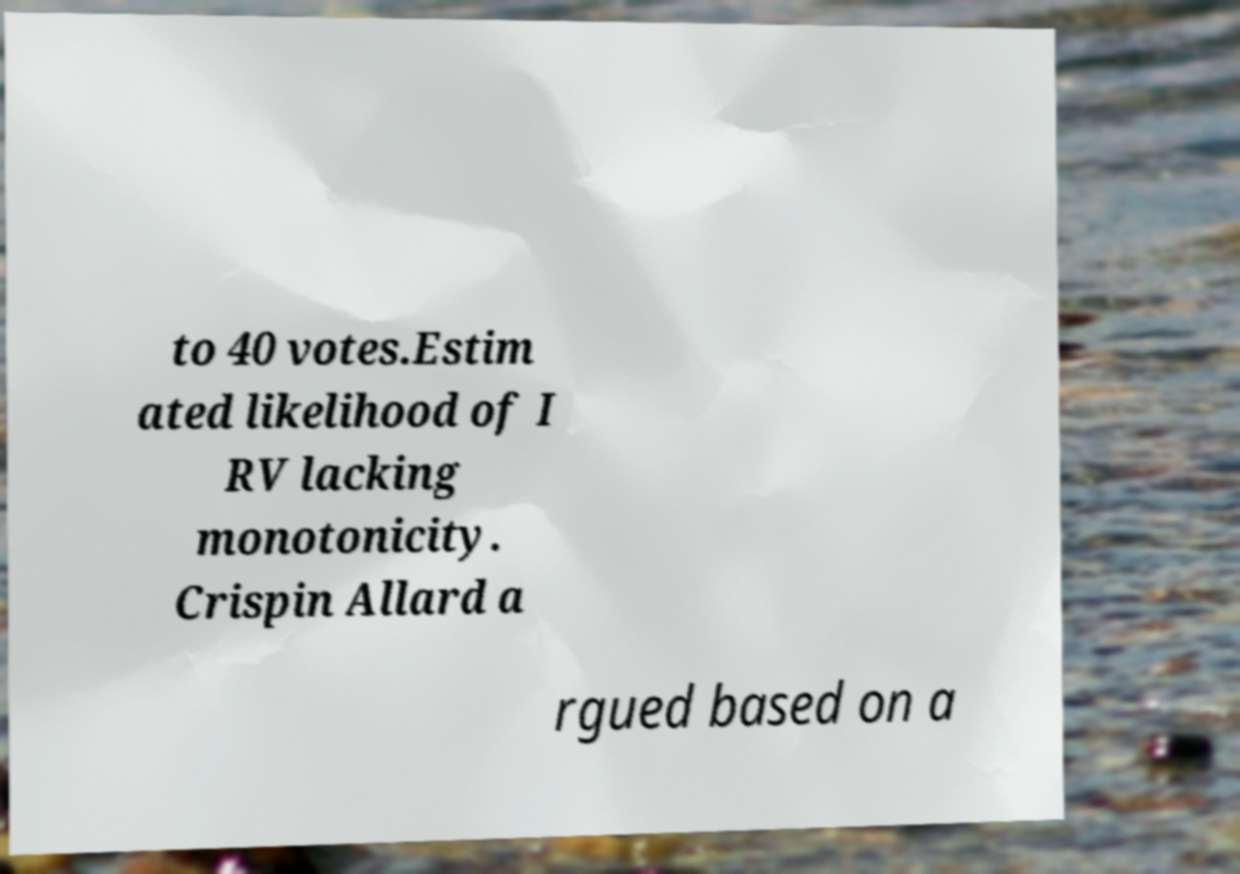I need the written content from this picture converted into text. Can you do that? to 40 votes.Estim ated likelihood of I RV lacking monotonicity. Crispin Allard a rgued based on a 